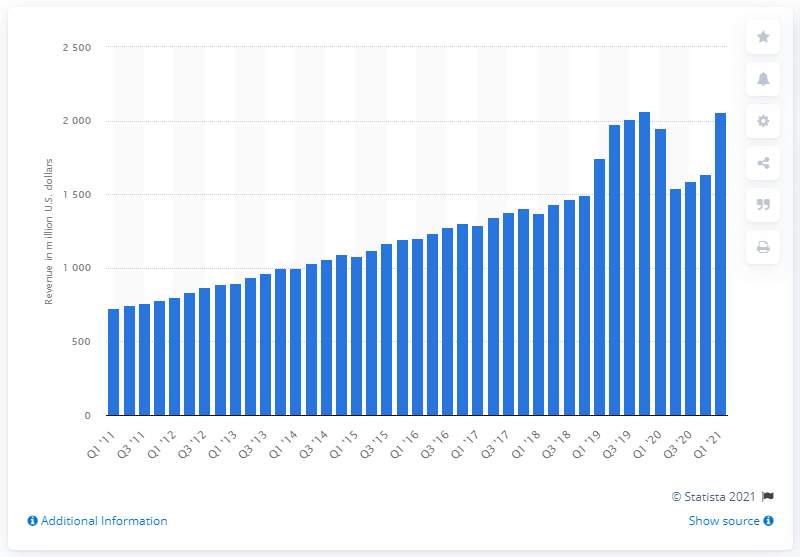Point out several critical features in this image. In the first quarter of 2021, the revenue of Sirius XM was approximately $1952. 